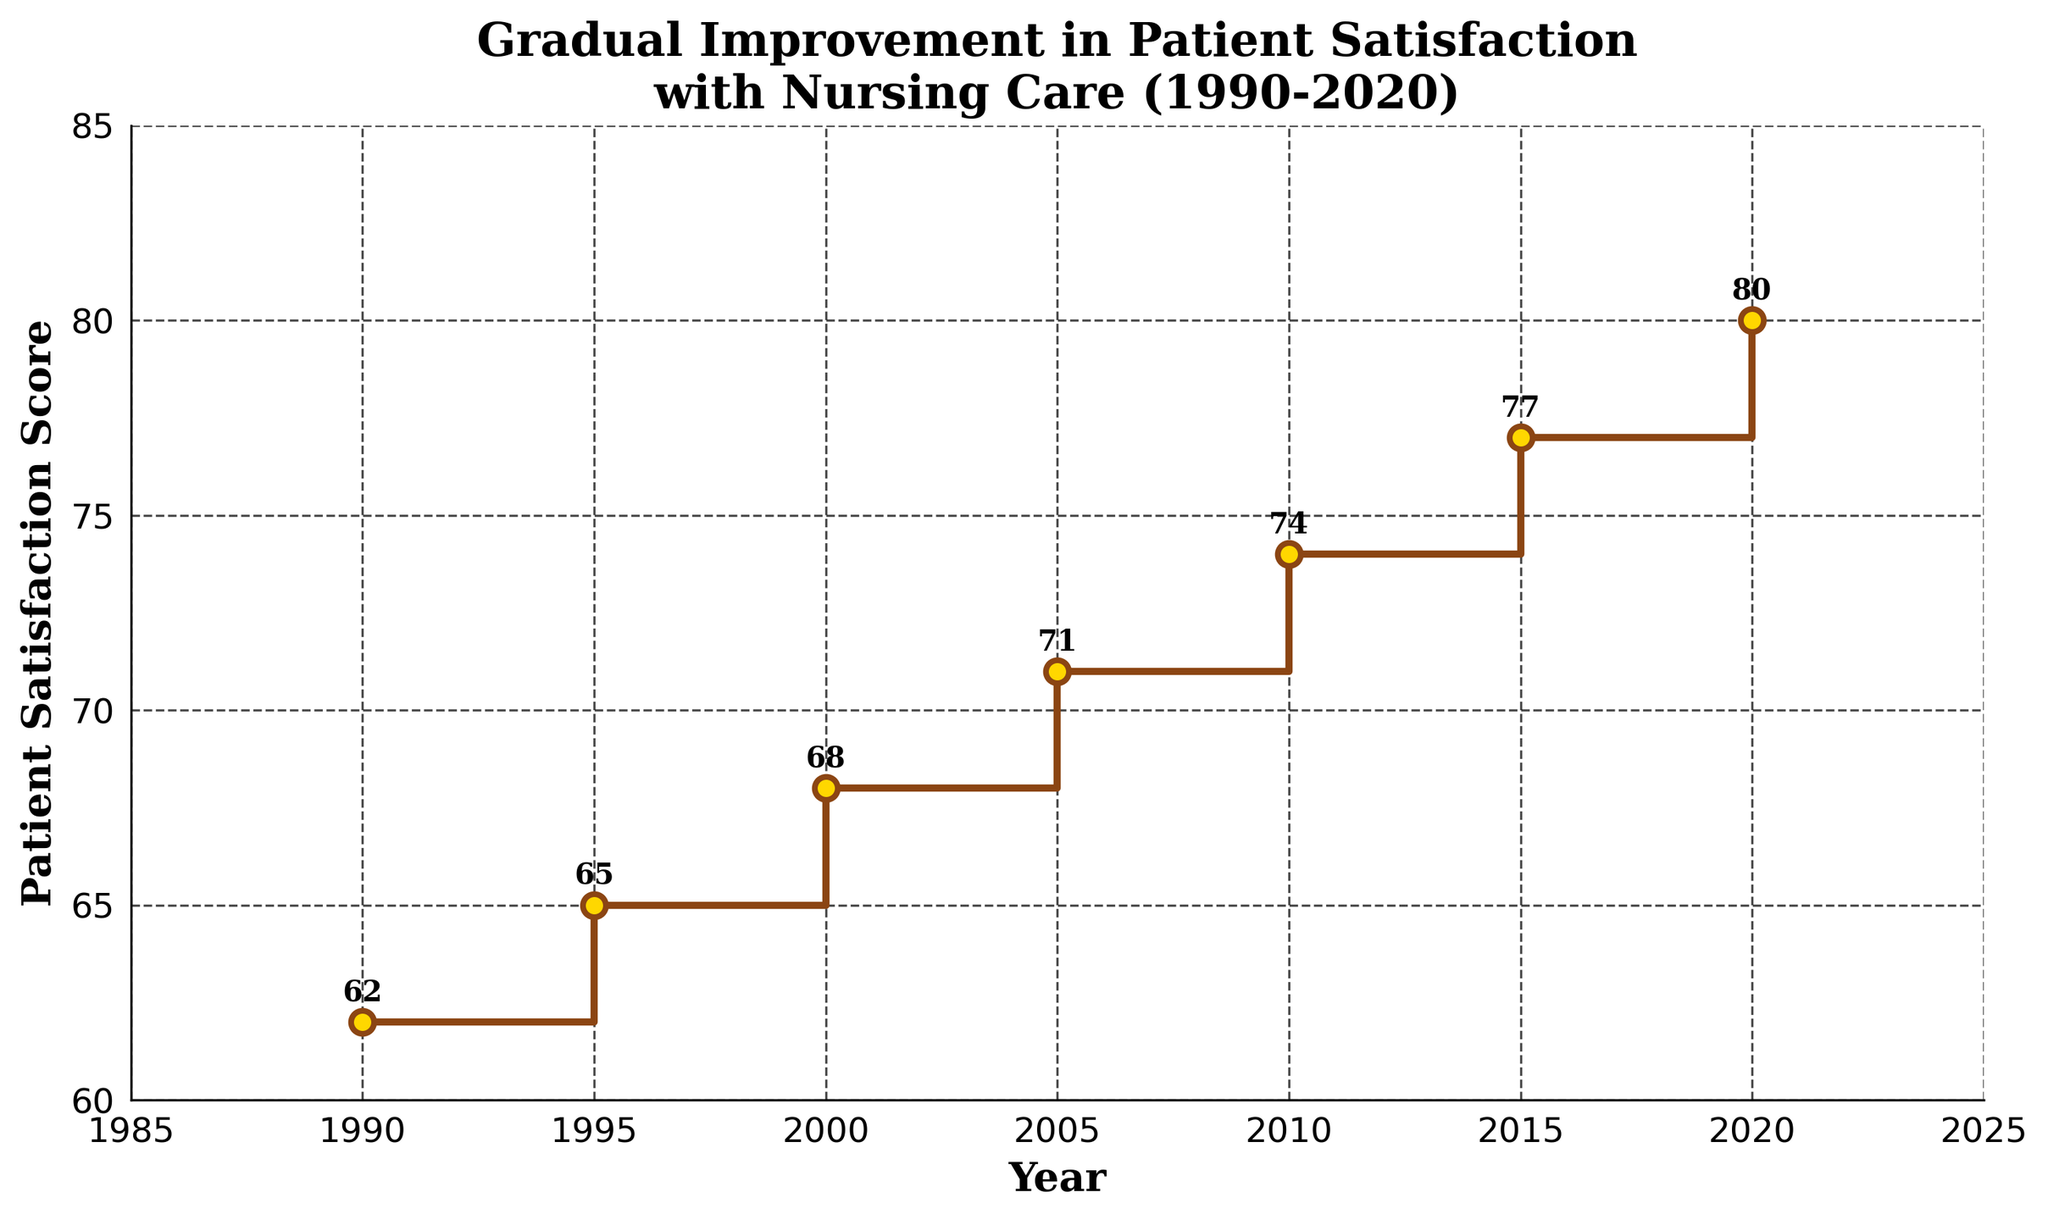What is the title of the figure? The title is displayed at the top of the figure in a larger font size. It helps to describe the content of the plot.
Answer: Gradual Improvement in Patient Satisfaction with Nursing Care (1990-2020) How many years are represented in the figure? Count the data points shown on the horizontal axis labeled "Year."
Answer: 7 What is the patient satisfaction score in 2015? Locate the year 2015 on the horizontal axis and find the corresponding point on the vertical axis labeled "Patient Satisfaction Score."
Answer: 77 What was the increase in patient satisfaction score from 1990 to 2020? Subtract the score in 1990 (62) from the score in 2020 (80). 80 - 62 = 18
Answer: 18 In which year did the patient satisfaction score first reach or exceed 70? Look for the first year where the score is at least 70 on the vertical axis. Check the corresponding year on the horizontal axis.
Answer: 2005 What is the average patient satisfaction score over the 30-year span? Add up all satisfaction scores (62+65+68+71+74+77+80 = 497) and divide by the number of years (7). Average = 497/7 = 71
Answer: 71 By how many points did the patient satisfaction score increase between 2000 and 2010? Subtract the score in 2000 (68) from the score in 2010 (74). 74 - 68 = 6
Answer: 6 In which interval did the patient satisfaction score increase the most? Compare the differences in scores between each pair of consecutive years. The largest difference is the greatest increase.
Answer: 2015 to 2020 Is there any year where the score remained the same as the previous interval? Check if the scores are identical between any two consecutive years in the dataset.
Answer: No What is the color of the markers used in the plot? Identify the color filled in the markers represented by small circles.
Answer: Gold 